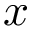<formula> <loc_0><loc_0><loc_500><loc_500>x</formula> 